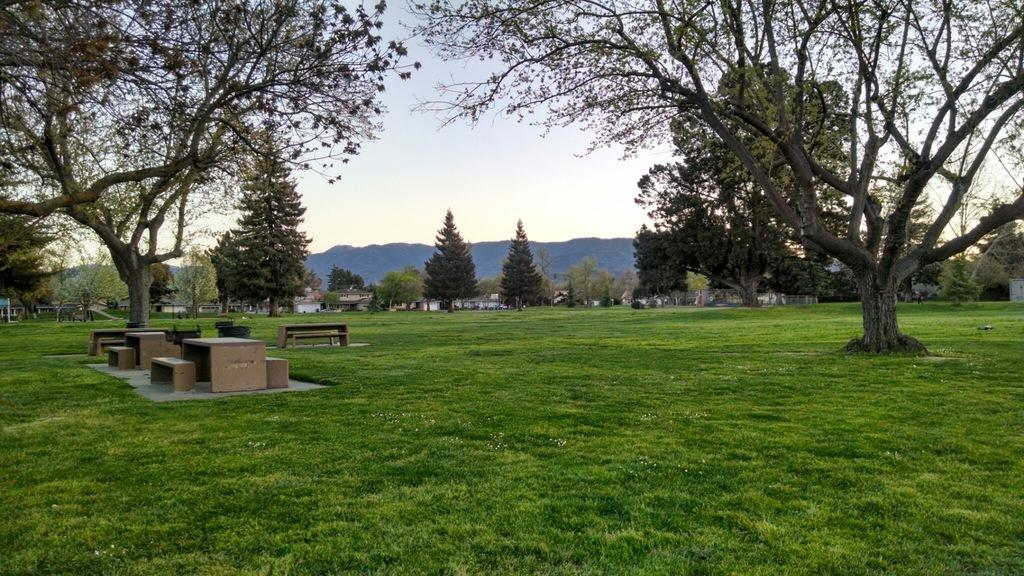What type of structures can be seen in the image? There are buildings in the image. What natural elements are present in the image? There are trees and mountains in the image. What type of seating is available in the foreground of the image? There are tables and benches in the foreground of the image. What is visible at the top of the image? The sky is visible at the top of the image. What type of ground cover is present at the bottom of the image? Grass is present at the bottom of the image. How many geese are sitting on the iron fence in the image? There are no geese or iron fences present in the image. What is the fifth building in the image? The image does not have a specific number of buildings, so it is not possible to identify a fifth building. 